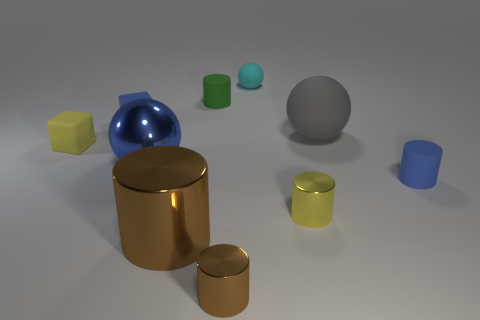Subtract all green cylinders. How many cylinders are left? 4 Subtract all tiny brown shiny cylinders. How many cylinders are left? 4 Subtract all red cylinders. Subtract all yellow blocks. How many cylinders are left? 5 Subtract all balls. How many objects are left? 7 Add 8 yellow metal cubes. How many yellow metal cubes exist? 8 Subtract 0 purple blocks. How many objects are left? 10 Subtract all yellow matte things. Subtract all large metallic objects. How many objects are left? 7 Add 2 large matte objects. How many large matte objects are left? 3 